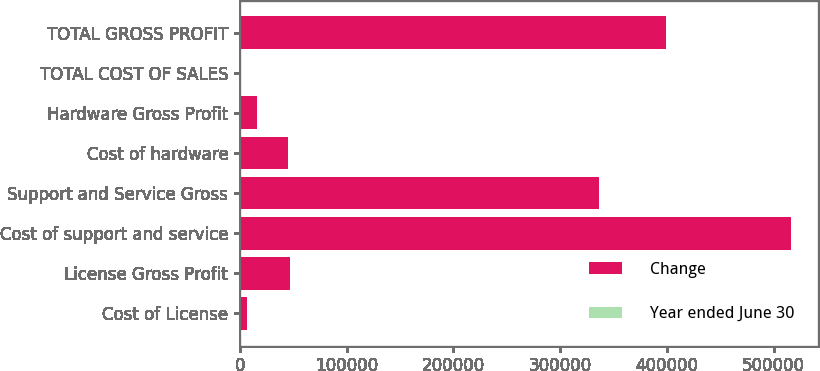Convert chart to OTSL. <chart><loc_0><loc_0><loc_500><loc_500><stacked_bar_chart><ecel><fcel>Cost of License<fcel>License Gross Profit<fcel>Cost of support and service<fcel>Support and Service Gross<fcel>Cost of hardware<fcel>Hardware Gross Profit<fcel>TOTAL COST OF SALES<fcel>TOTAL GROSS PROFIT<nl><fcel>Change<fcel>6285<fcel>46782<fcel>515917<fcel>336336<fcel>45361<fcel>16216<fcel>19<fcel>399334<nl><fcel>Year ended June 30<fcel>8<fcel>1<fcel>18<fcel>19<fcel>4<fcel>3<fcel>15<fcel>16<nl></chart> 